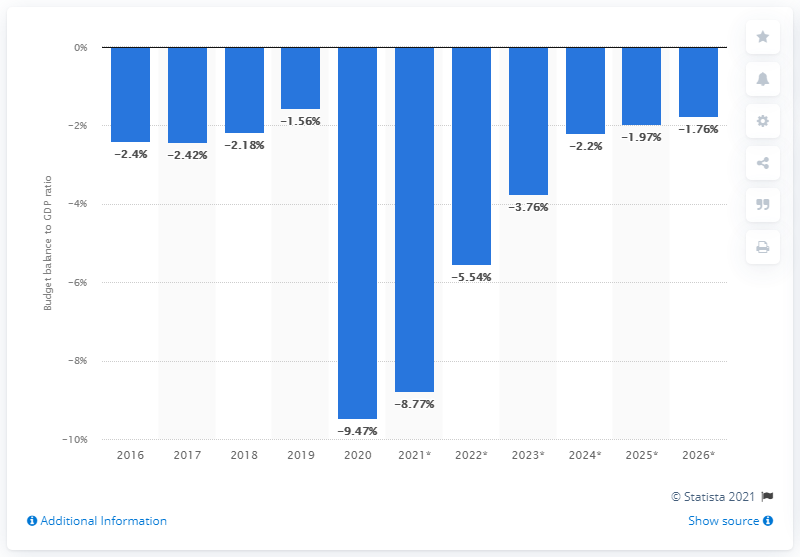Indicate a few pertinent items in this graphic. In 2020, Italy's budget balance came to an end. 